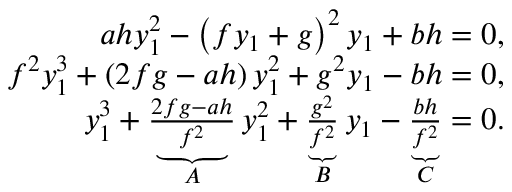<formula> <loc_0><loc_0><loc_500><loc_500>\begin{array} { r } { a h y _ { 1 } ^ { 2 } - \left ( f y _ { 1 } + g \right ) ^ { 2 } y _ { 1 } + b h = 0 , } \\ { f ^ { 2 } y _ { 1 } ^ { 3 } + \left ( 2 f g - a h \right ) y _ { 1 } ^ { 2 } + g ^ { 2 } y _ { 1 } - b h = 0 , } \\ { y _ { 1 } ^ { 3 } + \underbrace { \frac { 2 f g - a h } { f ^ { 2 } } } _ { A } y _ { 1 } ^ { 2 } + \underbrace { \frac { g ^ { 2 } } { f ^ { 2 } } } _ { B } y _ { 1 } - \underbrace { \frac { b h } { f ^ { 2 } } } _ { C } = 0 . } \end{array}</formula> 